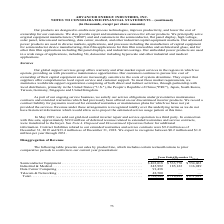According to Advanced Energy's financial document, What was the sales for Semiconductor Equipment in 2017? According to the financial document, $554,063 (in thousands). The relevant text states: "Semiconductor Equipment . $ 403,018 $ 533,770 $ 554,063 Industrial & Medical . 245,992 185,122 116,949 Data Center Computing . 91,438 — — Telecom & Network..." Also, What was the sales for Industrial & Medical in 2017? According to the financial document, 116,949 (in thousands). The relevant text states: "$ 554,063 Industrial & Medical . 245,992 185,122 116,949 Data Center Computing . 91,438 — — Telecom & Networking . 48,500 — — Total . $ 788,948 $ 718,892 $..." Also, What was the sales for Data Center Computing in 2019? According to the financial document, 91,438 (in thousands). The relevant text states: ". 245,992 185,122 116,949 Data Center Computing . 91,438 — — Telecom & Networking . 48,500 — — Total . $ 788,948 $ 718,892 $ 671,012..." Also, can you calculate: What was the change in sales of Industrial & Medical products between 2018 and 2019?  Based on the calculation: 245,992-185,122, the result is 60870 (in thousands). This is based on the information: "03,018 $ 533,770 $ 554,063 Industrial & Medical . 245,992 185,122 116,949 Data Center Computing . 91,438 — — Telecom & Networking . 48,500 — — Total . $ 788, 533,770 $ 554,063 Industrial & Medical . 2..." The key data points involved are: 185,122, 245,992. Also, can you calculate: What was the change in sales of Semiconductor Equipment between 2017 and 2018? Based on the calculation: $533,770-$554,063, the result is -20293 (in thousands). This is based on the information: "Semiconductor Equipment . $ 403,018 $ 533,770 $ 554,063 Industrial & Medical . 245,992 185,122 116,949 Data Center Computing . 91,438 — — Telecom Semiconductor Equipment . $ 403,018 $ 533,770 $ 554,06..." The key data points involved are: 533,770, 554,063. Also, can you calculate: What was the percentage change in total sales between 2018 and 2019? To answer this question, I need to perform calculations using the financial data. The calculation is: ($788,948-$718,892)/718,892, which equals 9.74 (percentage). This is based on the information: "8 — — Telecom & Networking . 48,500 — — Total . $ 788,948 $ 718,892 $ 671,012 com & Networking . 48,500 — — Total . $ 788,948 $ 718,892 $ 671,012..." The key data points involved are: 718,892, 788,948. 